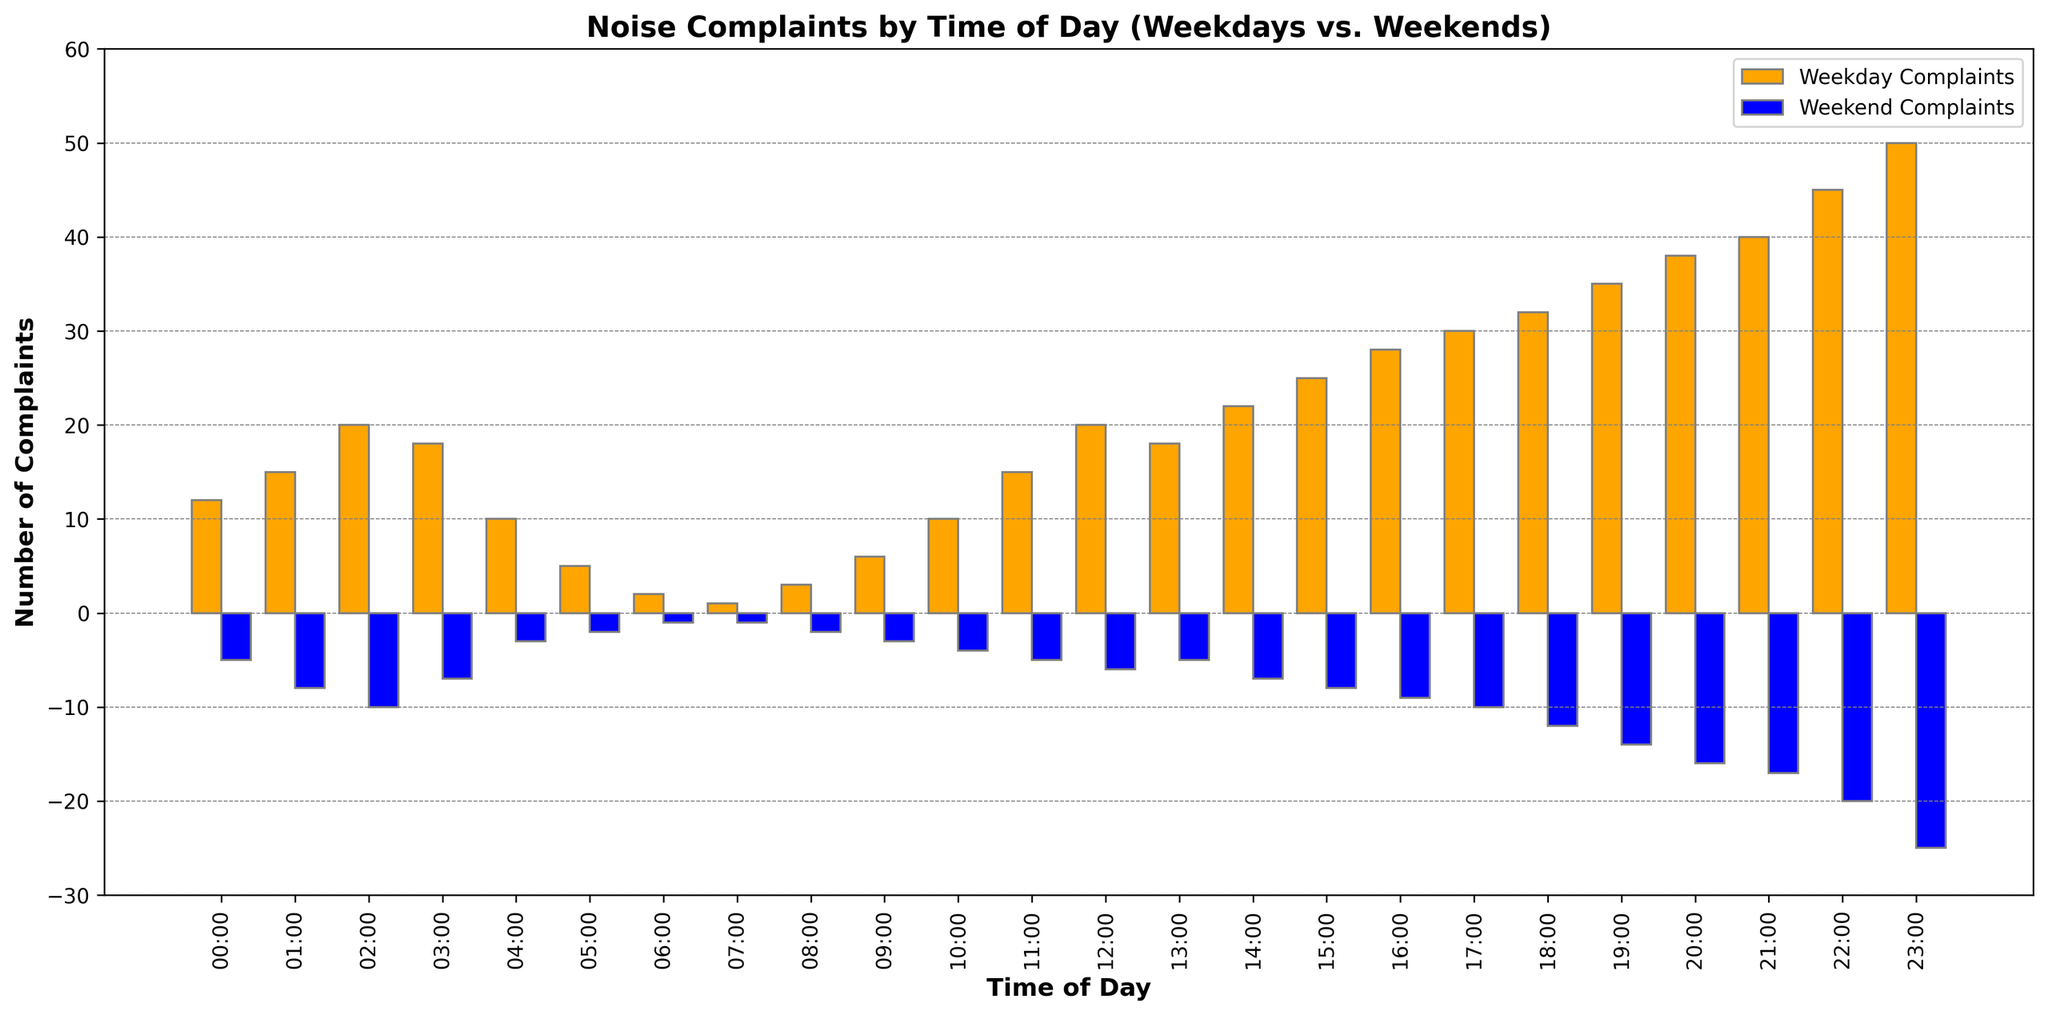What's the time of day with the highest number of weekday complaints? Look at the orange bars representing weekday complaints and identify the tallest one. The tallest orange bar is at 23:00 with 50 complaints.
Answer: 23:00 What's the total difference in complaints between weekdays and weekends at 02:00? Subtract the number of weekend complaints at 02:00 (-10) from the number of weekday complaints (20). Total difference = 20 - (-10) = 30.
Answer: 30 At which time of day is the difference in complaints between weekdays and weekends the smallest? Compare the differences between weekday and weekend complaints at each time of day. The smallest difference is at 06:00 with 2 weekday complaints and -1 weekend complaints (difference of 3).
Answer: 06:00 How many more complaints are there on weekdays than weekends at 21:00? Subtract the number of weekend complaints at 21:00 (-17) from the number of weekday complaints (40). The difference is 40 - (-17) = 57.
Answer: 57 What is the average number of weekday complaints between 00:00 and 04:00? Calculate the sum of weekday complaints from 00:00 to 04:00 (12 + 15 + 20 + 18 + 10 = 75) and divide by the number of time points (5). The average is 75 / 5 = 15.
Answer: 15 What is the sum of weekend complaints at 18:00, 19:00, and 20:00? Add the weekend complaints for 18:00 (-12), 19:00 (-14), and 20:00 (-16). The sum is -12 + (-14) + (-16) = -42.
Answer: -42 Which time of day shows an equal number of complaints for both weekdays and weekends? Check if any time of day has the same numeric value of complaints for both weekdays and weekends. None of the times of day have equal complaints for both.
Answer: None Are there more complaints at 12:00 on weekdays or weekends? Compare the weekday complaints (20) to the weekend complaints (-6) at 12:00. There are more complaints on weekdays.
Answer: Weekdays 